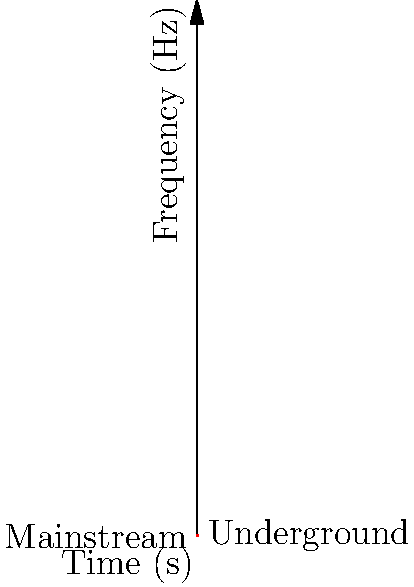As a radio DJ known for discovering underground hits, you're analyzing a new track's spectrogram to predict its mainstream potential. The image shows a spectrogram with frequency decreasing over time. Which characteristic of this spectrogram suggests the song is likely to transition from underground to mainstream, and why? To analyze the spectrogram and predict the song's potential to become mainstream, we need to consider the following steps:

1. Understand the spectrogram: The x-axis represents time, and the y-axis represents frequency. Each point represents the intensity of a particular frequency at a specific time.

2. Observe the trend: The spectrogram shows a clear downward trend in frequency over time.

3. Interpret the trend:
   a) Higher frequencies (top-left) are often associated with more complex, experimental, or "underground" sounds.
   b) Lower frequencies (bottom-right) are typically associated with simpler, more accessible, or "mainstream" sounds.

4. Analyze the transition: The gradual shift from higher to lower frequencies suggests a progression from complex to simpler elements.

5. Consider mainstream appeal: Songs that start with complex elements but gradually introduce simpler, more accessible patterns often have a higher potential to cross over from underground to mainstream.

6. Apply music industry knowledge: This transition can make the song more palatable to a wider audience while still maintaining some of its original underground appeal.

The characteristic that suggests the song is likely to transition from underground to mainstream is the gradual decrease in dominant frequencies over time. This pattern indicates a shift from complex, potentially underground elements to simpler, more accessible sounds that appeal to a broader audience.
Answer: Gradual decrease in dominant frequencies over time 